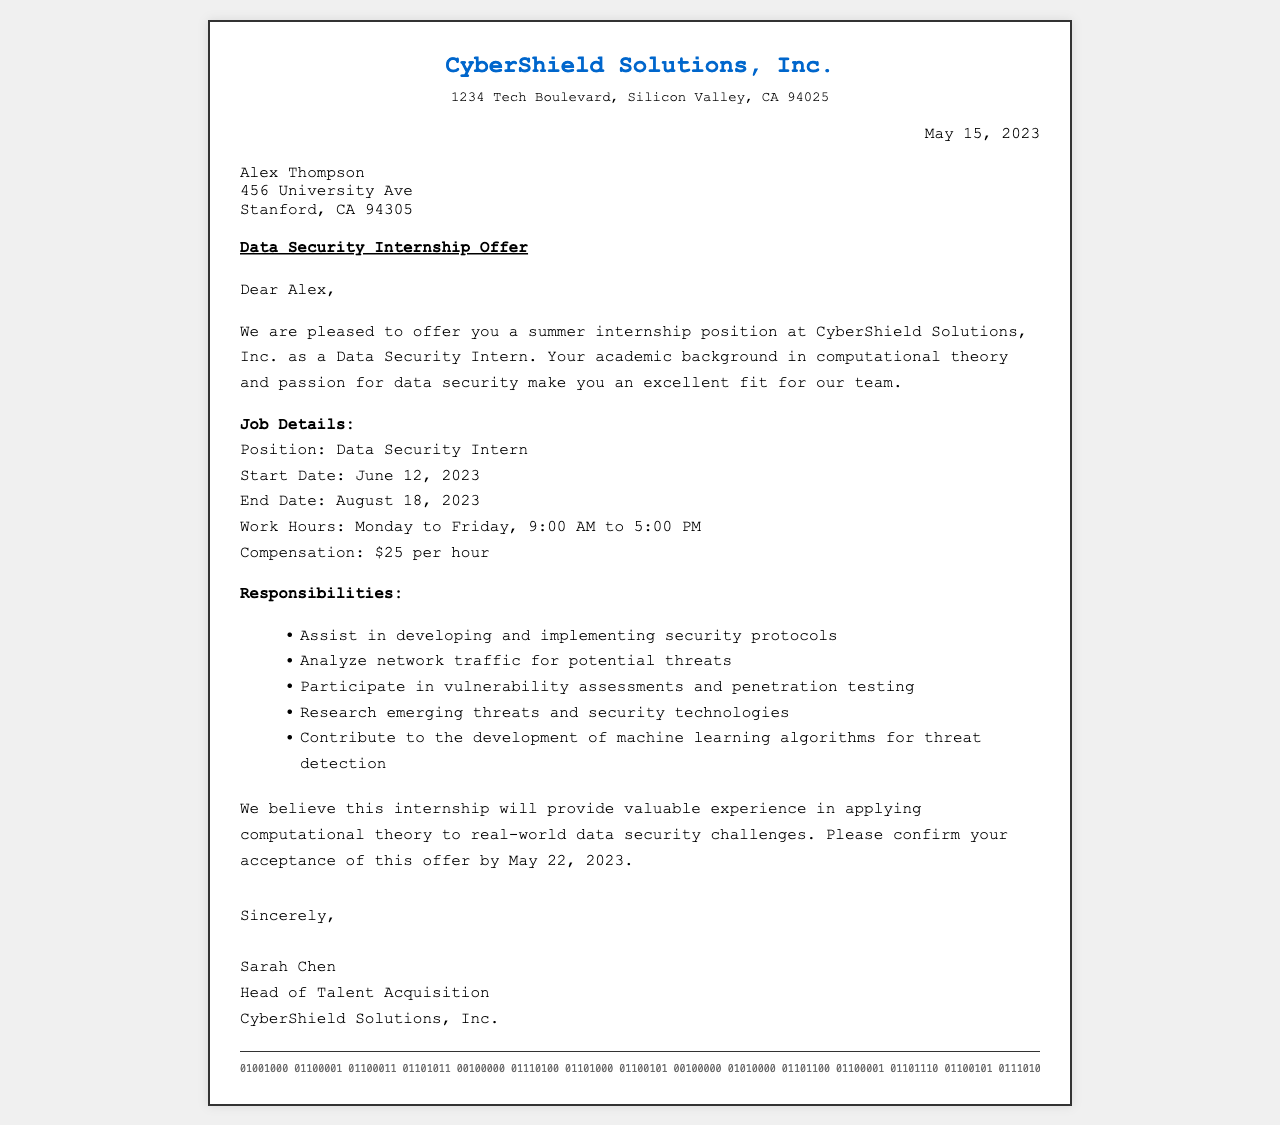What is the name of the company? The document mentions the company name at the top as "CyberShield Solutions, Inc."
Answer: CyberShield Solutions, Inc What is the position offered in the internship? The position offered is stated in the job details section of the document.
Answer: Data Security Intern What is the start date of the internship? The start date is specified in the job details section of the fax.
Answer: June 12, 2023 What is the end date of the internship? The end date is also provided in the job details section.
Answer: August 18, 2023 What is the hourly compensation for the internship? The compensation is mentioned under job details in the document.
Answer: $25 per hour Which days of the week will the intern work? The workdays are specified in the job details section of the document.
Answer: Monday to Friday What is one responsibility of the Data Security Intern? A specific responsibility is listed in the responsibilities section of the fax.
Answer: Assist in developing and implementing security protocols Who is the signer of the offer letter? The letter is signed by a specific person indicated in the signature section.
Answer: Sarah Chen By what date must the offer be accepted? The deadline for acceptance is mentioned in the content of the document.
Answer: May 22, 2023 What does the company believe this internship will provide? The document expresses a belief regarding the experience gained through the internship.
Answer: Valuable experience in applying computational theory to real-world data security challenges 